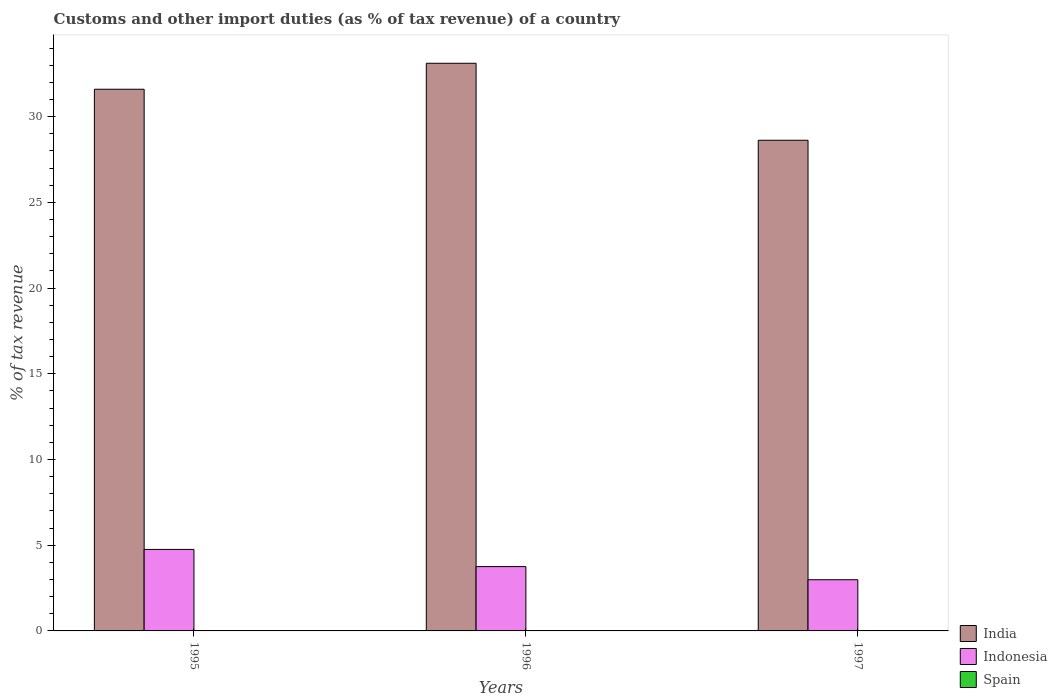How many groups of bars are there?
Your answer should be very brief. 3. Are the number of bars per tick equal to the number of legend labels?
Offer a very short reply. No. Are the number of bars on each tick of the X-axis equal?
Provide a short and direct response. No. How many bars are there on the 2nd tick from the right?
Provide a short and direct response. 2. What is the label of the 3rd group of bars from the left?
Keep it short and to the point. 1997. What is the percentage of tax revenue from customs in Indonesia in 1997?
Offer a terse response. 2.99. Across all years, what is the maximum percentage of tax revenue from customs in India?
Your answer should be very brief. 33.11. In which year was the percentage of tax revenue from customs in India maximum?
Provide a short and direct response. 1996. What is the total percentage of tax revenue from customs in Indonesia in the graph?
Provide a short and direct response. 11.49. What is the difference between the percentage of tax revenue from customs in Spain in 1995 and that in 1997?
Your answer should be very brief. 0. What is the difference between the percentage of tax revenue from customs in Spain in 1997 and the percentage of tax revenue from customs in India in 1996?
Offer a very short reply. -33.11. What is the average percentage of tax revenue from customs in Indonesia per year?
Your response must be concise. 3.83. In the year 1997, what is the difference between the percentage of tax revenue from customs in Spain and percentage of tax revenue from customs in India?
Your answer should be very brief. -28.62. In how many years, is the percentage of tax revenue from customs in Spain greater than 31 %?
Your answer should be compact. 0. What is the ratio of the percentage of tax revenue from customs in India in 1995 to that in 1997?
Provide a short and direct response. 1.1. Is the percentage of tax revenue from customs in India in 1995 less than that in 1996?
Your response must be concise. Yes. What is the difference between the highest and the second highest percentage of tax revenue from customs in India?
Make the answer very short. 1.52. What is the difference between the highest and the lowest percentage of tax revenue from customs in Spain?
Offer a terse response. 0. In how many years, is the percentage of tax revenue from customs in India greater than the average percentage of tax revenue from customs in India taken over all years?
Give a very brief answer. 2. Is the sum of the percentage of tax revenue from customs in India in 1996 and 1997 greater than the maximum percentage of tax revenue from customs in Indonesia across all years?
Your response must be concise. Yes. Is it the case that in every year, the sum of the percentage of tax revenue from customs in Spain and percentage of tax revenue from customs in Indonesia is greater than the percentage of tax revenue from customs in India?
Your answer should be compact. No. How many bars are there?
Keep it short and to the point. 8. Are all the bars in the graph horizontal?
Your answer should be compact. No. How many years are there in the graph?
Your answer should be compact. 3. What is the difference between two consecutive major ticks on the Y-axis?
Provide a succinct answer. 5. Where does the legend appear in the graph?
Your answer should be compact. Bottom right. What is the title of the graph?
Provide a short and direct response. Customs and other import duties (as % of tax revenue) of a country. What is the label or title of the Y-axis?
Provide a short and direct response. % of tax revenue. What is the % of tax revenue in India in 1995?
Your response must be concise. 31.6. What is the % of tax revenue of Indonesia in 1995?
Your answer should be very brief. 4.75. What is the % of tax revenue in Spain in 1995?
Make the answer very short. 0. What is the % of tax revenue of India in 1996?
Your response must be concise. 33.11. What is the % of tax revenue of Indonesia in 1996?
Provide a short and direct response. 3.75. What is the % of tax revenue of Spain in 1996?
Make the answer very short. 0. What is the % of tax revenue in India in 1997?
Offer a very short reply. 28.62. What is the % of tax revenue of Indonesia in 1997?
Ensure brevity in your answer.  2.99. What is the % of tax revenue in Spain in 1997?
Ensure brevity in your answer.  0. Across all years, what is the maximum % of tax revenue of India?
Ensure brevity in your answer.  33.11. Across all years, what is the maximum % of tax revenue in Indonesia?
Your response must be concise. 4.75. Across all years, what is the maximum % of tax revenue in Spain?
Ensure brevity in your answer.  0. Across all years, what is the minimum % of tax revenue of India?
Your answer should be compact. 28.62. Across all years, what is the minimum % of tax revenue in Indonesia?
Keep it short and to the point. 2.99. Across all years, what is the minimum % of tax revenue in Spain?
Offer a very short reply. 0. What is the total % of tax revenue of India in the graph?
Your answer should be compact. 93.33. What is the total % of tax revenue of Indonesia in the graph?
Give a very brief answer. 11.49. What is the total % of tax revenue of Spain in the graph?
Offer a terse response. 0.01. What is the difference between the % of tax revenue in India in 1995 and that in 1996?
Make the answer very short. -1.52. What is the difference between the % of tax revenue of Indonesia in 1995 and that in 1996?
Your answer should be very brief. 1. What is the difference between the % of tax revenue of India in 1995 and that in 1997?
Provide a short and direct response. 2.98. What is the difference between the % of tax revenue in Indonesia in 1995 and that in 1997?
Your answer should be very brief. 1.77. What is the difference between the % of tax revenue in Spain in 1995 and that in 1997?
Your response must be concise. 0. What is the difference between the % of tax revenue of India in 1996 and that in 1997?
Ensure brevity in your answer.  4.49. What is the difference between the % of tax revenue in Indonesia in 1996 and that in 1997?
Ensure brevity in your answer.  0.77. What is the difference between the % of tax revenue of India in 1995 and the % of tax revenue of Indonesia in 1996?
Keep it short and to the point. 27.85. What is the difference between the % of tax revenue of India in 1995 and the % of tax revenue of Indonesia in 1997?
Keep it short and to the point. 28.61. What is the difference between the % of tax revenue in India in 1995 and the % of tax revenue in Spain in 1997?
Offer a terse response. 31.59. What is the difference between the % of tax revenue in Indonesia in 1995 and the % of tax revenue in Spain in 1997?
Ensure brevity in your answer.  4.75. What is the difference between the % of tax revenue of India in 1996 and the % of tax revenue of Indonesia in 1997?
Offer a terse response. 30.13. What is the difference between the % of tax revenue in India in 1996 and the % of tax revenue in Spain in 1997?
Your response must be concise. 33.11. What is the difference between the % of tax revenue in Indonesia in 1996 and the % of tax revenue in Spain in 1997?
Make the answer very short. 3.75. What is the average % of tax revenue of India per year?
Ensure brevity in your answer.  31.11. What is the average % of tax revenue in Indonesia per year?
Give a very brief answer. 3.83. What is the average % of tax revenue of Spain per year?
Provide a succinct answer. 0. In the year 1995, what is the difference between the % of tax revenue of India and % of tax revenue of Indonesia?
Your answer should be compact. 26.84. In the year 1995, what is the difference between the % of tax revenue of India and % of tax revenue of Spain?
Your answer should be very brief. 31.59. In the year 1995, what is the difference between the % of tax revenue of Indonesia and % of tax revenue of Spain?
Offer a very short reply. 4.75. In the year 1996, what is the difference between the % of tax revenue in India and % of tax revenue in Indonesia?
Your answer should be compact. 29.36. In the year 1997, what is the difference between the % of tax revenue of India and % of tax revenue of Indonesia?
Provide a succinct answer. 25.63. In the year 1997, what is the difference between the % of tax revenue in India and % of tax revenue in Spain?
Provide a succinct answer. 28.62. In the year 1997, what is the difference between the % of tax revenue of Indonesia and % of tax revenue of Spain?
Ensure brevity in your answer.  2.98. What is the ratio of the % of tax revenue in India in 1995 to that in 1996?
Your answer should be compact. 0.95. What is the ratio of the % of tax revenue of Indonesia in 1995 to that in 1996?
Keep it short and to the point. 1.27. What is the ratio of the % of tax revenue of India in 1995 to that in 1997?
Provide a succinct answer. 1.1. What is the ratio of the % of tax revenue of Indonesia in 1995 to that in 1997?
Make the answer very short. 1.59. What is the ratio of the % of tax revenue in Spain in 1995 to that in 1997?
Provide a succinct answer. 1.11. What is the ratio of the % of tax revenue in India in 1996 to that in 1997?
Your answer should be very brief. 1.16. What is the ratio of the % of tax revenue of Indonesia in 1996 to that in 1997?
Your answer should be compact. 1.26. What is the difference between the highest and the second highest % of tax revenue in India?
Provide a succinct answer. 1.52. What is the difference between the highest and the lowest % of tax revenue of India?
Your response must be concise. 4.49. What is the difference between the highest and the lowest % of tax revenue of Indonesia?
Offer a very short reply. 1.77. What is the difference between the highest and the lowest % of tax revenue in Spain?
Your answer should be very brief. 0. 